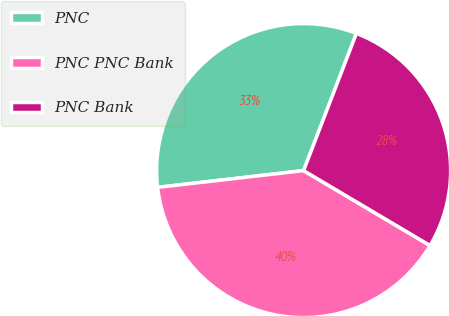Convert chart to OTSL. <chart><loc_0><loc_0><loc_500><loc_500><pie_chart><fcel>PNC<fcel>PNC PNC Bank<fcel>PNC Bank<nl><fcel>32.67%<fcel>39.67%<fcel>27.67%<nl></chart> 